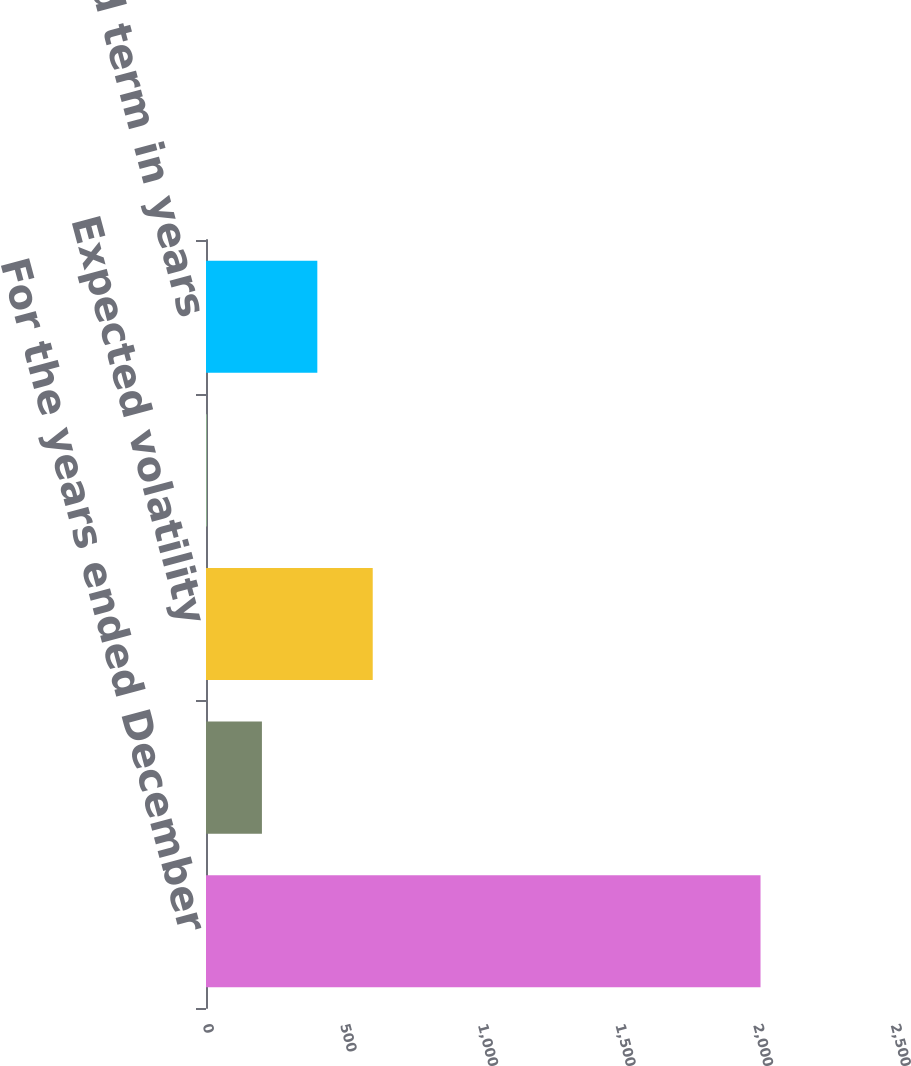Convert chart to OTSL. <chart><loc_0><loc_0><loc_500><loc_500><bar_chart><fcel>For the years ended December<fcel>Dividend yields<fcel>Expected volatility<fcel>Risk-free interest rates<fcel>Expected term in years<nl><fcel>2015<fcel>203.21<fcel>605.83<fcel>1.9<fcel>404.52<nl></chart> 